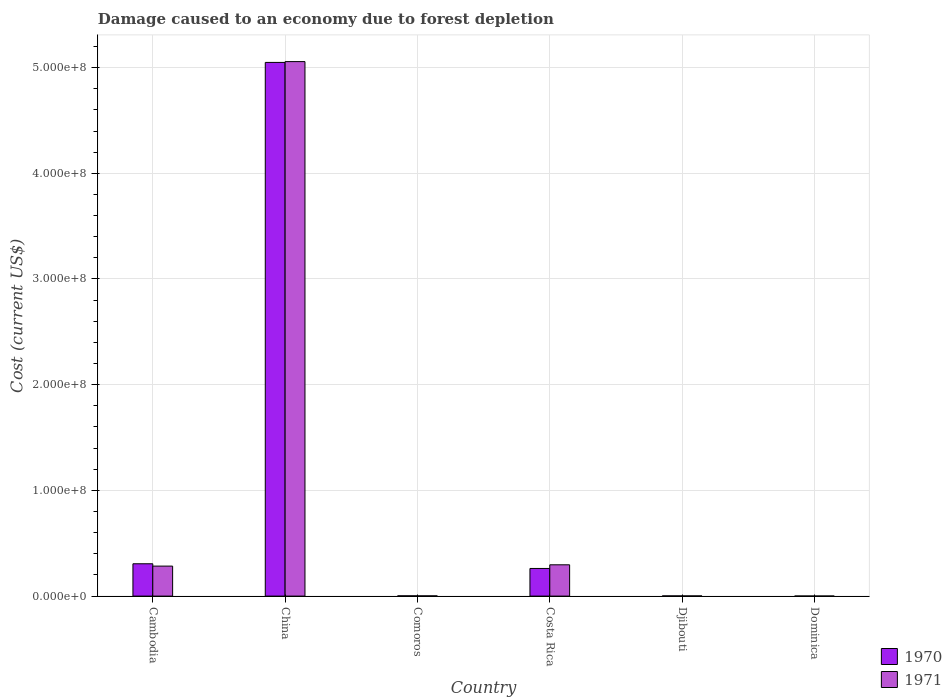How many groups of bars are there?
Make the answer very short. 6. Are the number of bars per tick equal to the number of legend labels?
Your answer should be compact. Yes. How many bars are there on the 5th tick from the right?
Your response must be concise. 2. What is the cost of damage caused due to forest depletion in 1970 in Costa Rica?
Offer a very short reply. 2.61e+07. Across all countries, what is the maximum cost of damage caused due to forest depletion in 1971?
Your response must be concise. 5.06e+08. Across all countries, what is the minimum cost of damage caused due to forest depletion in 1971?
Provide a short and direct response. 5.09e+04. In which country was the cost of damage caused due to forest depletion in 1970 minimum?
Ensure brevity in your answer.  Dominica. What is the total cost of damage caused due to forest depletion in 1970 in the graph?
Make the answer very short. 5.62e+08. What is the difference between the cost of damage caused due to forest depletion in 1971 in Djibouti and that in Dominica?
Give a very brief answer. 1.22e+05. What is the difference between the cost of damage caused due to forest depletion in 1970 in China and the cost of damage caused due to forest depletion in 1971 in Costa Rica?
Make the answer very short. 4.75e+08. What is the average cost of damage caused due to forest depletion in 1970 per country?
Make the answer very short. 9.37e+07. What is the difference between the cost of damage caused due to forest depletion of/in 1971 and cost of damage caused due to forest depletion of/in 1970 in Dominica?
Provide a short and direct response. -8949.07. What is the ratio of the cost of damage caused due to forest depletion in 1970 in Djibouti to that in Dominica?
Provide a succinct answer. 3.09. Is the difference between the cost of damage caused due to forest depletion in 1971 in Comoros and Dominica greater than the difference between the cost of damage caused due to forest depletion in 1970 in Comoros and Dominica?
Your response must be concise. No. What is the difference between the highest and the second highest cost of damage caused due to forest depletion in 1970?
Provide a succinct answer. 4.74e+08. What is the difference between the highest and the lowest cost of damage caused due to forest depletion in 1971?
Provide a succinct answer. 5.06e+08. In how many countries, is the cost of damage caused due to forest depletion in 1971 greater than the average cost of damage caused due to forest depletion in 1971 taken over all countries?
Keep it short and to the point. 1. What does the 1st bar from the left in Comoros represents?
Your answer should be compact. 1970. How many bars are there?
Give a very brief answer. 12. How many countries are there in the graph?
Make the answer very short. 6. What is the difference between two consecutive major ticks on the Y-axis?
Make the answer very short. 1.00e+08. Are the values on the major ticks of Y-axis written in scientific E-notation?
Offer a very short reply. Yes. Does the graph contain grids?
Offer a very short reply. Yes. Where does the legend appear in the graph?
Offer a very short reply. Bottom right. What is the title of the graph?
Offer a terse response. Damage caused to an economy due to forest depletion. Does "2008" appear as one of the legend labels in the graph?
Offer a very short reply. No. What is the label or title of the X-axis?
Your answer should be compact. Country. What is the label or title of the Y-axis?
Your answer should be very brief. Cost (current US$). What is the Cost (current US$) in 1970 in Cambodia?
Your response must be concise. 3.06e+07. What is the Cost (current US$) of 1971 in Cambodia?
Your answer should be compact. 2.84e+07. What is the Cost (current US$) in 1970 in China?
Offer a very short reply. 5.05e+08. What is the Cost (current US$) in 1971 in China?
Give a very brief answer. 5.06e+08. What is the Cost (current US$) in 1970 in Comoros?
Provide a short and direct response. 2.49e+05. What is the Cost (current US$) of 1971 in Comoros?
Offer a very short reply. 2.13e+05. What is the Cost (current US$) in 1970 in Costa Rica?
Give a very brief answer. 2.61e+07. What is the Cost (current US$) in 1971 in Costa Rica?
Offer a very short reply. 2.96e+07. What is the Cost (current US$) in 1970 in Djibouti?
Your answer should be compact. 1.85e+05. What is the Cost (current US$) in 1971 in Djibouti?
Keep it short and to the point. 1.73e+05. What is the Cost (current US$) in 1970 in Dominica?
Your answer should be compact. 5.98e+04. What is the Cost (current US$) of 1971 in Dominica?
Give a very brief answer. 5.09e+04. Across all countries, what is the maximum Cost (current US$) in 1970?
Provide a short and direct response. 5.05e+08. Across all countries, what is the maximum Cost (current US$) in 1971?
Keep it short and to the point. 5.06e+08. Across all countries, what is the minimum Cost (current US$) of 1970?
Your answer should be compact. 5.98e+04. Across all countries, what is the minimum Cost (current US$) in 1971?
Provide a short and direct response. 5.09e+04. What is the total Cost (current US$) in 1970 in the graph?
Ensure brevity in your answer.  5.62e+08. What is the total Cost (current US$) in 1971 in the graph?
Offer a very short reply. 5.64e+08. What is the difference between the Cost (current US$) of 1970 in Cambodia and that in China?
Your answer should be compact. -4.74e+08. What is the difference between the Cost (current US$) in 1971 in Cambodia and that in China?
Provide a short and direct response. -4.77e+08. What is the difference between the Cost (current US$) in 1970 in Cambodia and that in Comoros?
Your answer should be very brief. 3.03e+07. What is the difference between the Cost (current US$) of 1971 in Cambodia and that in Comoros?
Provide a short and direct response. 2.82e+07. What is the difference between the Cost (current US$) in 1970 in Cambodia and that in Costa Rica?
Your response must be concise. 4.44e+06. What is the difference between the Cost (current US$) of 1971 in Cambodia and that in Costa Rica?
Make the answer very short. -1.23e+06. What is the difference between the Cost (current US$) in 1970 in Cambodia and that in Djibouti?
Ensure brevity in your answer.  3.04e+07. What is the difference between the Cost (current US$) of 1971 in Cambodia and that in Djibouti?
Your answer should be compact. 2.82e+07. What is the difference between the Cost (current US$) of 1970 in Cambodia and that in Dominica?
Give a very brief answer. 3.05e+07. What is the difference between the Cost (current US$) of 1971 in Cambodia and that in Dominica?
Your response must be concise. 2.83e+07. What is the difference between the Cost (current US$) in 1970 in China and that in Comoros?
Make the answer very short. 5.05e+08. What is the difference between the Cost (current US$) in 1971 in China and that in Comoros?
Provide a short and direct response. 5.05e+08. What is the difference between the Cost (current US$) in 1970 in China and that in Costa Rica?
Your response must be concise. 4.79e+08. What is the difference between the Cost (current US$) in 1971 in China and that in Costa Rica?
Your answer should be very brief. 4.76e+08. What is the difference between the Cost (current US$) in 1970 in China and that in Djibouti?
Offer a terse response. 5.05e+08. What is the difference between the Cost (current US$) of 1971 in China and that in Djibouti?
Make the answer very short. 5.05e+08. What is the difference between the Cost (current US$) of 1970 in China and that in Dominica?
Keep it short and to the point. 5.05e+08. What is the difference between the Cost (current US$) in 1971 in China and that in Dominica?
Offer a terse response. 5.06e+08. What is the difference between the Cost (current US$) of 1970 in Comoros and that in Costa Rica?
Give a very brief answer. -2.59e+07. What is the difference between the Cost (current US$) in 1971 in Comoros and that in Costa Rica?
Your response must be concise. -2.94e+07. What is the difference between the Cost (current US$) in 1970 in Comoros and that in Djibouti?
Give a very brief answer. 6.42e+04. What is the difference between the Cost (current US$) of 1971 in Comoros and that in Djibouti?
Provide a succinct answer. 3.93e+04. What is the difference between the Cost (current US$) of 1970 in Comoros and that in Dominica?
Provide a short and direct response. 1.89e+05. What is the difference between the Cost (current US$) of 1971 in Comoros and that in Dominica?
Keep it short and to the point. 1.62e+05. What is the difference between the Cost (current US$) in 1970 in Costa Rica and that in Djibouti?
Give a very brief answer. 2.60e+07. What is the difference between the Cost (current US$) of 1971 in Costa Rica and that in Djibouti?
Provide a short and direct response. 2.94e+07. What is the difference between the Cost (current US$) in 1970 in Costa Rica and that in Dominica?
Provide a succinct answer. 2.61e+07. What is the difference between the Cost (current US$) of 1971 in Costa Rica and that in Dominica?
Provide a succinct answer. 2.96e+07. What is the difference between the Cost (current US$) of 1970 in Djibouti and that in Dominica?
Provide a succinct answer. 1.25e+05. What is the difference between the Cost (current US$) of 1971 in Djibouti and that in Dominica?
Make the answer very short. 1.22e+05. What is the difference between the Cost (current US$) in 1970 in Cambodia and the Cost (current US$) in 1971 in China?
Ensure brevity in your answer.  -4.75e+08. What is the difference between the Cost (current US$) of 1970 in Cambodia and the Cost (current US$) of 1971 in Comoros?
Provide a short and direct response. 3.04e+07. What is the difference between the Cost (current US$) in 1970 in Cambodia and the Cost (current US$) in 1971 in Costa Rica?
Keep it short and to the point. 9.86e+05. What is the difference between the Cost (current US$) of 1970 in Cambodia and the Cost (current US$) of 1971 in Djibouti?
Ensure brevity in your answer.  3.04e+07. What is the difference between the Cost (current US$) of 1970 in Cambodia and the Cost (current US$) of 1971 in Dominica?
Provide a short and direct response. 3.05e+07. What is the difference between the Cost (current US$) in 1970 in China and the Cost (current US$) in 1971 in Comoros?
Offer a very short reply. 5.05e+08. What is the difference between the Cost (current US$) of 1970 in China and the Cost (current US$) of 1971 in Costa Rica?
Offer a terse response. 4.75e+08. What is the difference between the Cost (current US$) of 1970 in China and the Cost (current US$) of 1971 in Djibouti?
Ensure brevity in your answer.  5.05e+08. What is the difference between the Cost (current US$) in 1970 in China and the Cost (current US$) in 1971 in Dominica?
Provide a succinct answer. 5.05e+08. What is the difference between the Cost (current US$) of 1970 in Comoros and the Cost (current US$) of 1971 in Costa Rica?
Give a very brief answer. -2.94e+07. What is the difference between the Cost (current US$) of 1970 in Comoros and the Cost (current US$) of 1971 in Djibouti?
Keep it short and to the point. 7.56e+04. What is the difference between the Cost (current US$) of 1970 in Comoros and the Cost (current US$) of 1971 in Dominica?
Provide a short and direct response. 1.98e+05. What is the difference between the Cost (current US$) of 1970 in Costa Rica and the Cost (current US$) of 1971 in Djibouti?
Your answer should be very brief. 2.60e+07. What is the difference between the Cost (current US$) in 1970 in Costa Rica and the Cost (current US$) in 1971 in Dominica?
Keep it short and to the point. 2.61e+07. What is the difference between the Cost (current US$) of 1970 in Djibouti and the Cost (current US$) of 1971 in Dominica?
Your answer should be compact. 1.34e+05. What is the average Cost (current US$) of 1970 per country?
Keep it short and to the point. 9.37e+07. What is the average Cost (current US$) of 1971 per country?
Provide a succinct answer. 9.40e+07. What is the difference between the Cost (current US$) in 1970 and Cost (current US$) in 1971 in Cambodia?
Provide a short and direct response. 2.21e+06. What is the difference between the Cost (current US$) of 1970 and Cost (current US$) of 1971 in China?
Your response must be concise. -7.69e+05. What is the difference between the Cost (current US$) of 1970 and Cost (current US$) of 1971 in Comoros?
Your response must be concise. 3.63e+04. What is the difference between the Cost (current US$) in 1970 and Cost (current US$) in 1971 in Costa Rica?
Offer a very short reply. -3.45e+06. What is the difference between the Cost (current US$) in 1970 and Cost (current US$) in 1971 in Djibouti?
Your response must be concise. 1.14e+04. What is the difference between the Cost (current US$) in 1970 and Cost (current US$) in 1971 in Dominica?
Your answer should be very brief. 8949.07. What is the ratio of the Cost (current US$) in 1970 in Cambodia to that in China?
Keep it short and to the point. 0.06. What is the ratio of the Cost (current US$) in 1971 in Cambodia to that in China?
Make the answer very short. 0.06. What is the ratio of the Cost (current US$) in 1970 in Cambodia to that in Comoros?
Provide a succinct answer. 122.87. What is the ratio of the Cost (current US$) in 1971 in Cambodia to that in Comoros?
Provide a succinct answer. 133.44. What is the ratio of the Cost (current US$) in 1970 in Cambodia to that in Costa Rica?
Ensure brevity in your answer.  1.17. What is the ratio of the Cost (current US$) of 1971 in Cambodia to that in Costa Rica?
Provide a succinct answer. 0.96. What is the ratio of the Cost (current US$) in 1970 in Cambodia to that in Djibouti?
Provide a short and direct response. 165.57. What is the ratio of the Cost (current US$) of 1971 in Cambodia to that in Djibouti?
Give a very brief answer. 163.72. What is the ratio of the Cost (current US$) in 1970 in Cambodia to that in Dominica?
Ensure brevity in your answer.  511.38. What is the ratio of the Cost (current US$) in 1971 in Cambodia to that in Dominica?
Offer a very short reply. 557.86. What is the ratio of the Cost (current US$) in 1970 in China to that in Comoros?
Make the answer very short. 2028.18. What is the ratio of the Cost (current US$) of 1971 in China to that in Comoros?
Keep it short and to the point. 2377.93. What is the ratio of the Cost (current US$) of 1970 in China to that in Costa Rica?
Keep it short and to the point. 19.31. What is the ratio of the Cost (current US$) of 1971 in China to that in Costa Rica?
Offer a very short reply. 17.08. What is the ratio of the Cost (current US$) of 1970 in China to that in Djibouti?
Ensure brevity in your answer.  2732.97. What is the ratio of the Cost (current US$) in 1971 in China to that in Djibouti?
Provide a short and direct response. 2917.64. What is the ratio of the Cost (current US$) of 1970 in China to that in Dominica?
Your answer should be compact. 8441.17. What is the ratio of the Cost (current US$) of 1971 in China to that in Dominica?
Keep it short and to the point. 9941.41. What is the ratio of the Cost (current US$) of 1970 in Comoros to that in Costa Rica?
Your answer should be very brief. 0.01. What is the ratio of the Cost (current US$) of 1971 in Comoros to that in Costa Rica?
Provide a short and direct response. 0.01. What is the ratio of the Cost (current US$) in 1970 in Comoros to that in Djibouti?
Your answer should be compact. 1.35. What is the ratio of the Cost (current US$) of 1971 in Comoros to that in Djibouti?
Your answer should be compact. 1.23. What is the ratio of the Cost (current US$) of 1970 in Comoros to that in Dominica?
Make the answer very short. 4.16. What is the ratio of the Cost (current US$) in 1971 in Comoros to that in Dominica?
Offer a terse response. 4.18. What is the ratio of the Cost (current US$) in 1970 in Costa Rica to that in Djibouti?
Your response must be concise. 141.54. What is the ratio of the Cost (current US$) of 1971 in Costa Rica to that in Djibouti?
Your response must be concise. 170.8. What is the ratio of the Cost (current US$) in 1970 in Costa Rica to that in Dominica?
Ensure brevity in your answer.  437.18. What is the ratio of the Cost (current US$) of 1971 in Costa Rica to that in Dominica?
Offer a terse response. 581.97. What is the ratio of the Cost (current US$) in 1970 in Djibouti to that in Dominica?
Provide a succinct answer. 3.09. What is the ratio of the Cost (current US$) of 1971 in Djibouti to that in Dominica?
Make the answer very short. 3.41. What is the difference between the highest and the second highest Cost (current US$) of 1970?
Provide a short and direct response. 4.74e+08. What is the difference between the highest and the second highest Cost (current US$) of 1971?
Provide a succinct answer. 4.76e+08. What is the difference between the highest and the lowest Cost (current US$) in 1970?
Offer a terse response. 5.05e+08. What is the difference between the highest and the lowest Cost (current US$) in 1971?
Your answer should be compact. 5.06e+08. 